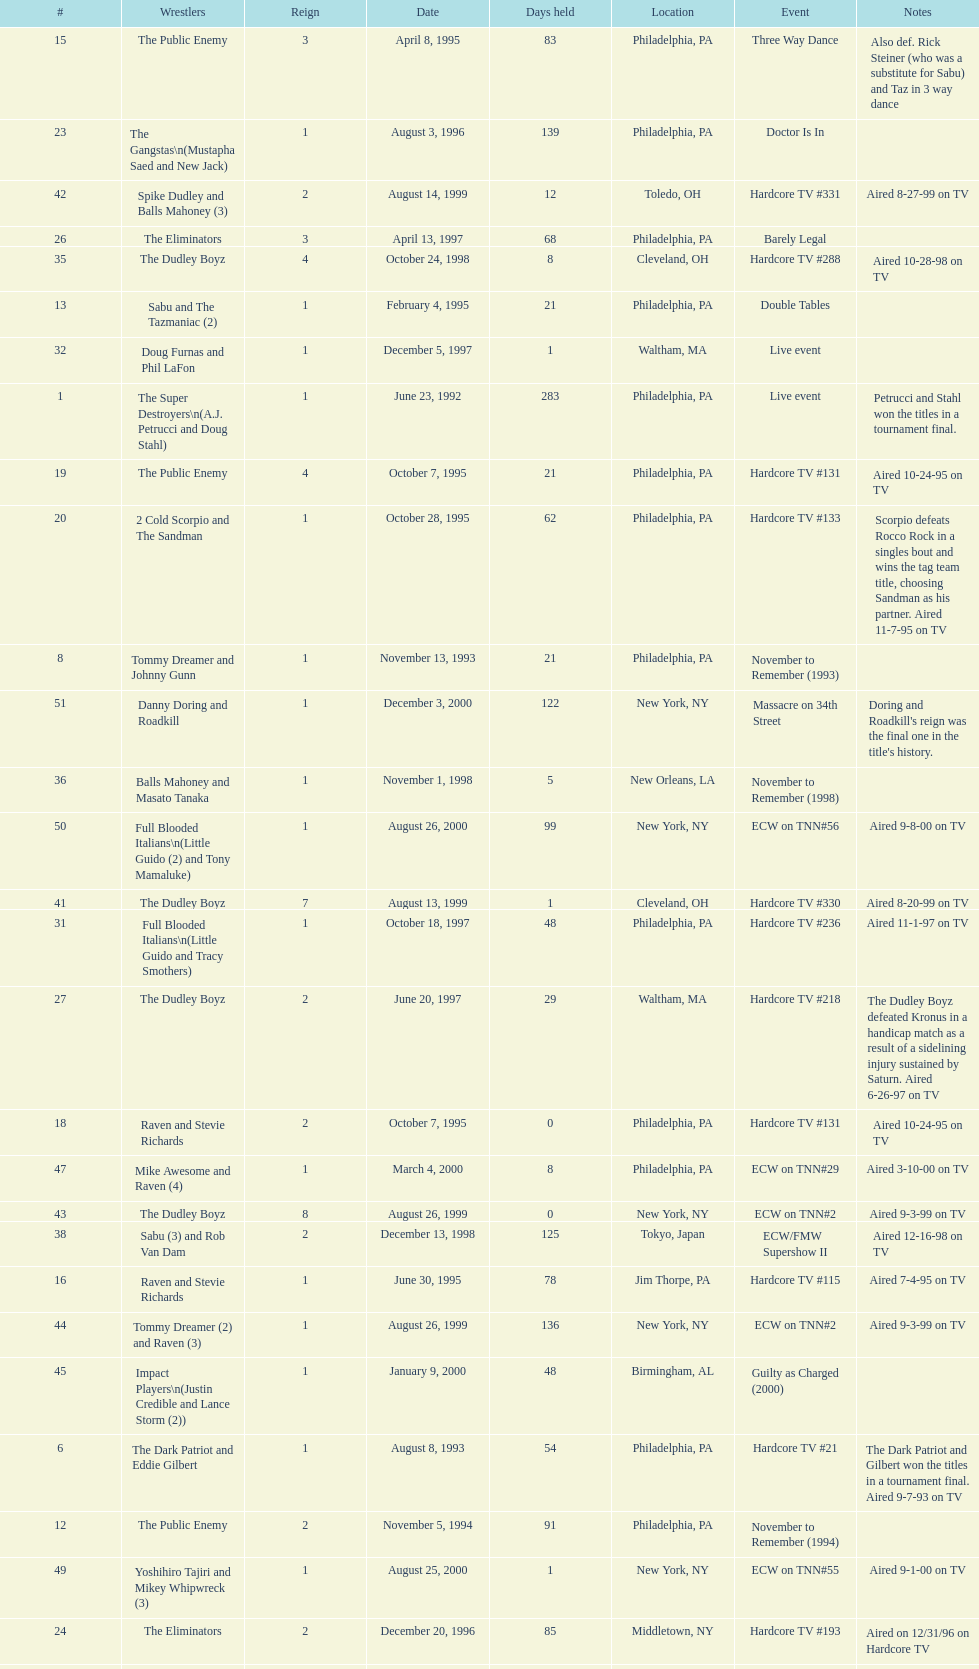What is the total days held on # 1st? 283. 